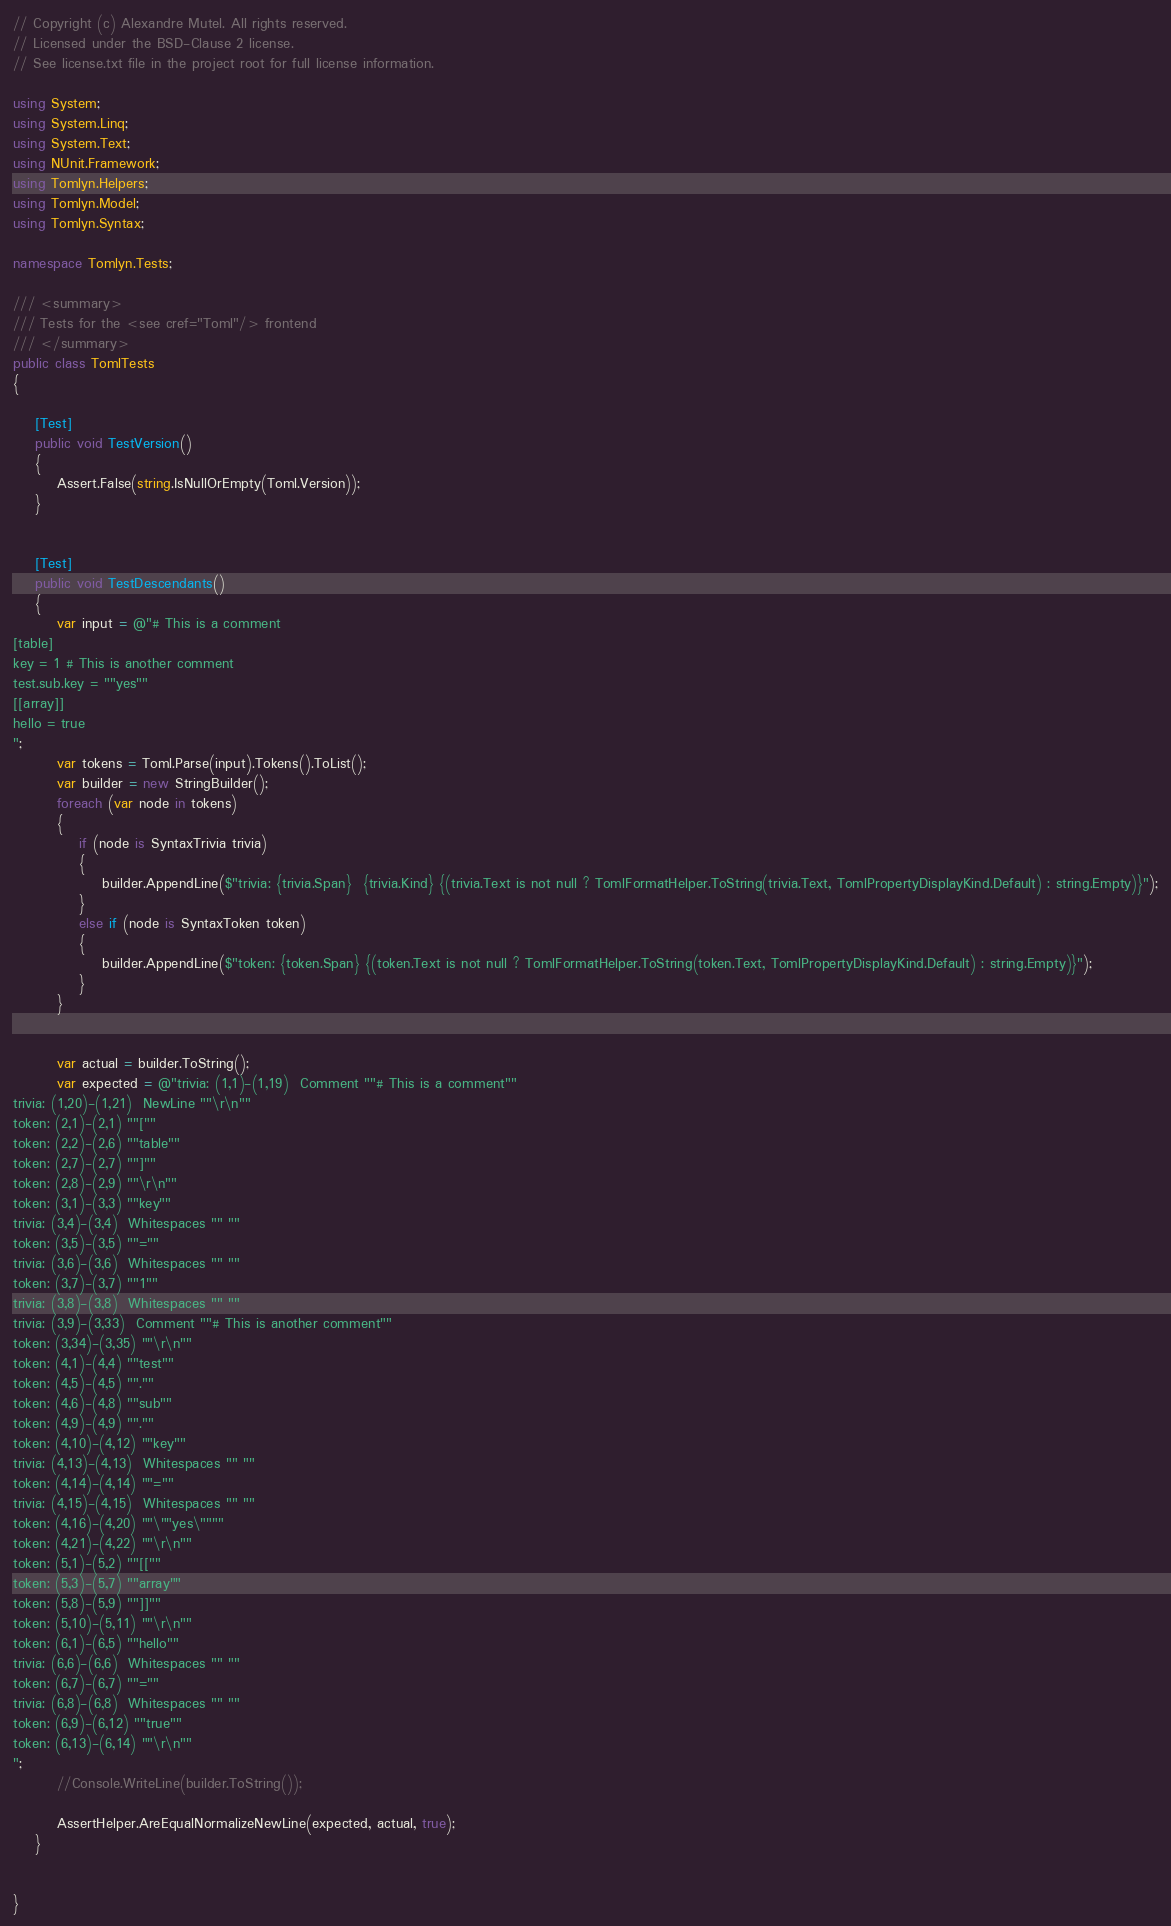<code> <loc_0><loc_0><loc_500><loc_500><_C#_>// Copyright (c) Alexandre Mutel. All rights reserved.
// Licensed under the BSD-Clause 2 license.
// See license.txt file in the project root for full license information.

using System;
using System.Linq;
using System.Text;
using NUnit.Framework;
using Tomlyn.Helpers;
using Tomlyn.Model;
using Tomlyn.Syntax;

namespace Tomlyn.Tests;

/// <summary>
/// Tests for the <see cref="Toml"/> frontend
/// </summary>
public class TomlTests
{

    [Test]
    public void TestVersion()
    {
        Assert.False(string.IsNullOrEmpty(Toml.Version));
    }


    [Test]
    public void TestDescendants()
    {
        var input = @"# This is a comment
[table]
key = 1 # This is another comment
test.sub.key = ""yes""
[[array]]
hello = true
";
        var tokens = Toml.Parse(input).Tokens().ToList();
        var builder = new StringBuilder();
        foreach (var node in tokens)
        {
            if (node is SyntaxTrivia trivia)
            {
                builder.AppendLine($"trivia: {trivia.Span}  {trivia.Kind} {(trivia.Text is not null ? TomlFormatHelper.ToString(trivia.Text, TomlPropertyDisplayKind.Default) : string.Empty)}");
            }
            else if (node is SyntaxToken token)
            {
                builder.AppendLine($"token: {token.Span} {(token.Text is not null ? TomlFormatHelper.ToString(token.Text, TomlPropertyDisplayKind.Default) : string.Empty)}");
            }
        }


        var actual = builder.ToString();
        var expected = @"trivia: (1,1)-(1,19)  Comment ""# This is a comment""
trivia: (1,20)-(1,21)  NewLine ""\r\n""
token: (2,1)-(2,1) ""[""
token: (2,2)-(2,6) ""table""
token: (2,7)-(2,7) ""]""
token: (2,8)-(2,9) ""\r\n""
token: (3,1)-(3,3) ""key""
trivia: (3,4)-(3,4)  Whitespaces "" ""
token: (3,5)-(3,5) ""=""
trivia: (3,6)-(3,6)  Whitespaces "" ""
token: (3,7)-(3,7) ""1""
trivia: (3,8)-(3,8)  Whitespaces "" ""
trivia: (3,9)-(3,33)  Comment ""# This is another comment""
token: (3,34)-(3,35) ""\r\n""
token: (4,1)-(4,4) ""test""
token: (4,5)-(4,5) "".""
token: (4,6)-(4,8) ""sub""
token: (4,9)-(4,9) "".""
token: (4,10)-(4,12) ""key""
trivia: (4,13)-(4,13)  Whitespaces "" ""
token: (4,14)-(4,14) ""=""
trivia: (4,15)-(4,15)  Whitespaces "" ""
token: (4,16)-(4,20) ""\""yes\""""
token: (4,21)-(4,22) ""\r\n""
token: (5,1)-(5,2) ""[[""
token: (5,3)-(5,7) ""array""
token: (5,8)-(5,9) ""]]""
token: (5,10)-(5,11) ""\r\n""
token: (6,1)-(6,5) ""hello""
trivia: (6,6)-(6,6)  Whitespaces "" ""
token: (6,7)-(6,7) ""=""
trivia: (6,8)-(6,8)  Whitespaces "" ""
token: (6,9)-(6,12) ""true""
token: (6,13)-(6,14) ""\r\n""
";
        //Console.WriteLine(builder.ToString());

        AssertHelper.AreEqualNormalizeNewLine(expected, actual, true);
    }


}</code> 